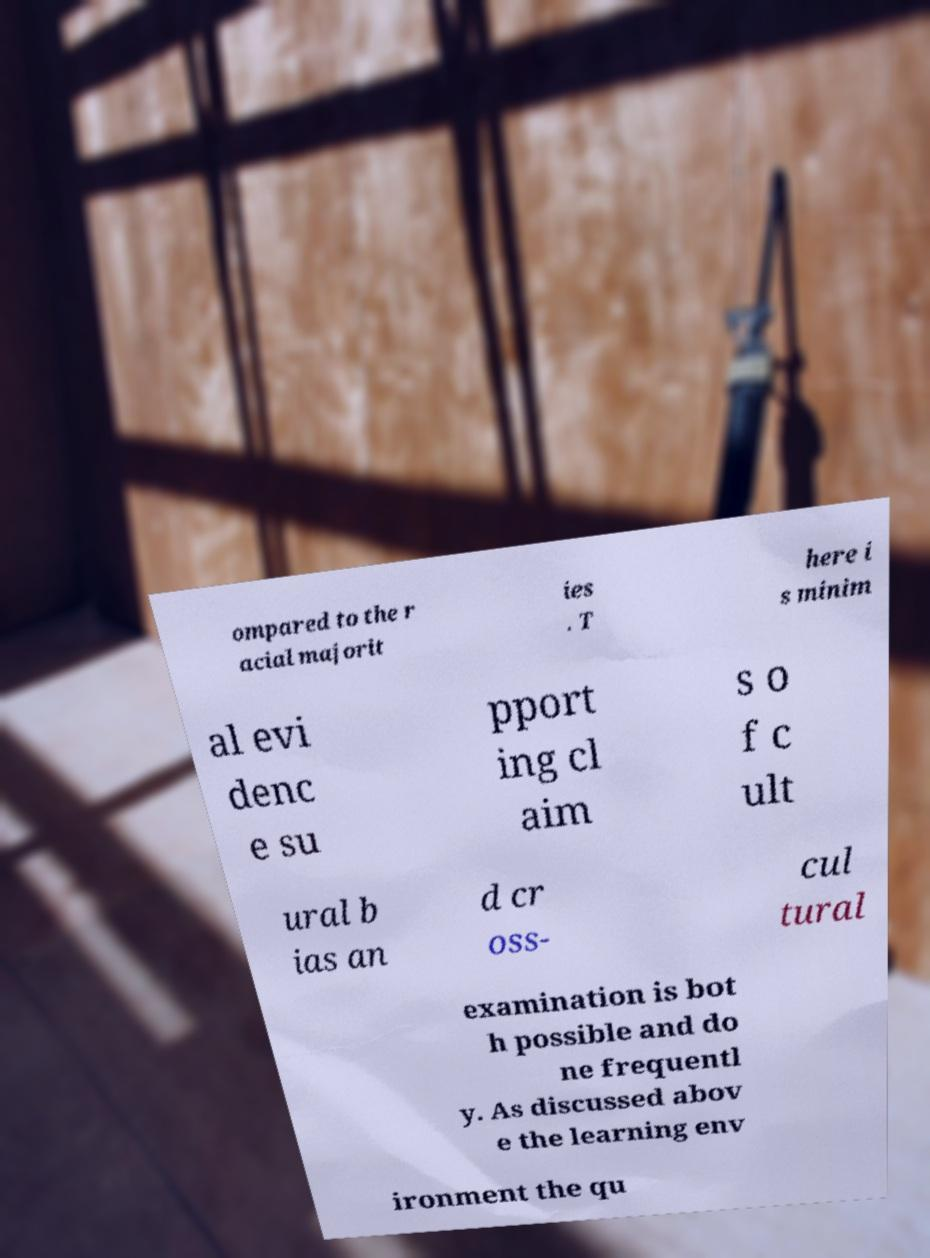What messages or text are displayed in this image? I need them in a readable, typed format. ompared to the r acial majorit ies . T here i s minim al evi denc e su pport ing cl aim s o f c ult ural b ias an d cr oss- cul tural examination is bot h possible and do ne frequentl y. As discussed abov e the learning env ironment the qu 